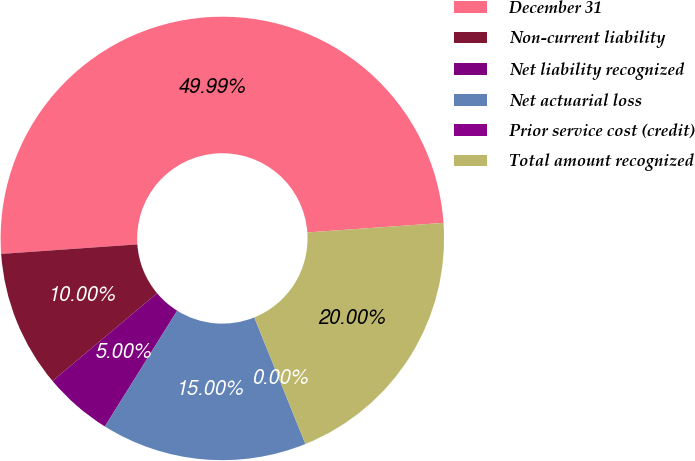Convert chart to OTSL. <chart><loc_0><loc_0><loc_500><loc_500><pie_chart><fcel>December 31<fcel>Non-current liability<fcel>Net liability recognized<fcel>Net actuarial loss<fcel>Prior service cost (credit)<fcel>Total amount recognized<nl><fcel>49.99%<fcel>10.0%<fcel>5.0%<fcel>15.0%<fcel>0.0%<fcel>20.0%<nl></chart> 